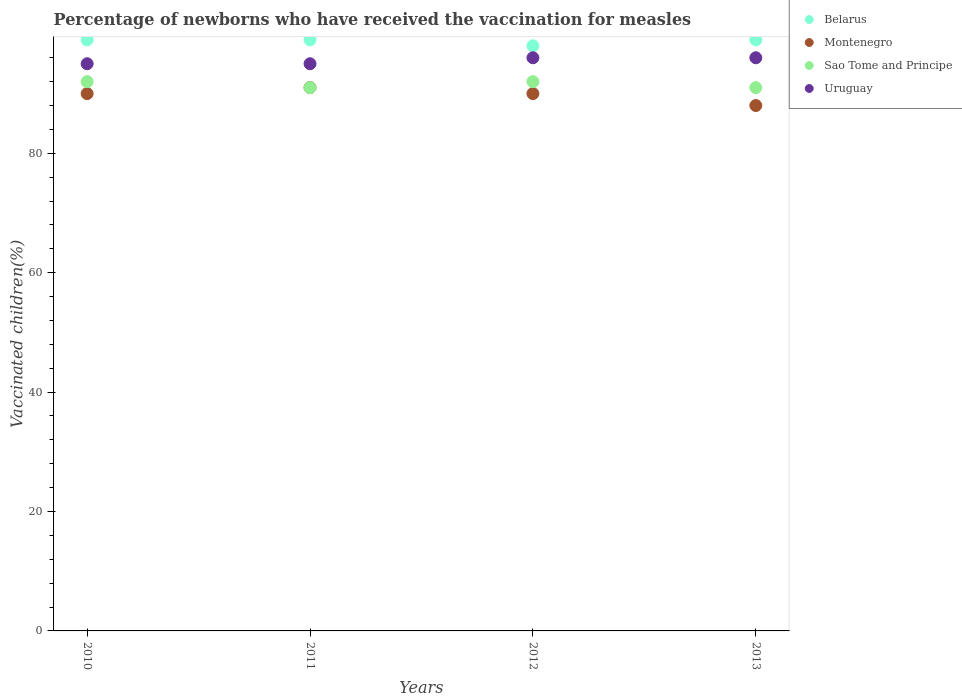How many different coloured dotlines are there?
Your answer should be very brief. 4. Is the number of dotlines equal to the number of legend labels?
Ensure brevity in your answer.  Yes. Across all years, what is the maximum percentage of vaccinated children in Sao Tome and Principe?
Provide a succinct answer. 92. In which year was the percentage of vaccinated children in Montenegro maximum?
Offer a terse response. 2011. What is the total percentage of vaccinated children in Montenegro in the graph?
Provide a short and direct response. 359. What is the difference between the percentage of vaccinated children in Uruguay in 2011 and that in 2013?
Ensure brevity in your answer.  -1. What is the difference between the percentage of vaccinated children in Sao Tome and Principe in 2011 and the percentage of vaccinated children in Montenegro in 2010?
Offer a terse response. 1. What is the average percentage of vaccinated children in Uruguay per year?
Your response must be concise. 95.5. In how many years, is the percentage of vaccinated children in Uruguay greater than 36 %?
Give a very brief answer. 4. What is the ratio of the percentage of vaccinated children in Belarus in 2012 to that in 2013?
Your answer should be very brief. 0.99. Is the percentage of vaccinated children in Belarus in 2010 less than that in 2011?
Ensure brevity in your answer.  No. What is the difference between the highest and the second highest percentage of vaccinated children in Montenegro?
Offer a very short reply. 1. Is it the case that in every year, the sum of the percentage of vaccinated children in Sao Tome and Principe and percentage of vaccinated children in Montenegro  is greater than the percentage of vaccinated children in Uruguay?
Offer a terse response. Yes. Does the percentage of vaccinated children in Belarus monotonically increase over the years?
Make the answer very short. No. Is the percentage of vaccinated children in Uruguay strictly less than the percentage of vaccinated children in Sao Tome and Principe over the years?
Offer a very short reply. No. How many years are there in the graph?
Your answer should be compact. 4. What is the difference between two consecutive major ticks on the Y-axis?
Offer a terse response. 20. Does the graph contain any zero values?
Make the answer very short. No. Does the graph contain grids?
Make the answer very short. No. Where does the legend appear in the graph?
Make the answer very short. Top right. What is the title of the graph?
Offer a terse response. Percentage of newborns who have received the vaccination for measles. What is the label or title of the Y-axis?
Make the answer very short. Vaccinated children(%). What is the Vaccinated children(%) of Belarus in 2010?
Your answer should be very brief. 99. What is the Vaccinated children(%) in Montenegro in 2010?
Your answer should be compact. 90. What is the Vaccinated children(%) of Sao Tome and Principe in 2010?
Ensure brevity in your answer.  92. What is the Vaccinated children(%) of Uruguay in 2010?
Ensure brevity in your answer.  95. What is the Vaccinated children(%) of Montenegro in 2011?
Provide a short and direct response. 91. What is the Vaccinated children(%) of Sao Tome and Principe in 2011?
Provide a succinct answer. 91. What is the Vaccinated children(%) in Uruguay in 2011?
Offer a terse response. 95. What is the Vaccinated children(%) in Montenegro in 2012?
Your response must be concise. 90. What is the Vaccinated children(%) in Sao Tome and Principe in 2012?
Your answer should be compact. 92. What is the Vaccinated children(%) of Uruguay in 2012?
Your answer should be compact. 96. What is the Vaccinated children(%) in Montenegro in 2013?
Your answer should be very brief. 88. What is the Vaccinated children(%) in Sao Tome and Principe in 2013?
Make the answer very short. 91. What is the Vaccinated children(%) of Uruguay in 2013?
Provide a succinct answer. 96. Across all years, what is the maximum Vaccinated children(%) of Montenegro?
Offer a terse response. 91. Across all years, what is the maximum Vaccinated children(%) in Sao Tome and Principe?
Keep it short and to the point. 92. Across all years, what is the maximum Vaccinated children(%) of Uruguay?
Ensure brevity in your answer.  96. Across all years, what is the minimum Vaccinated children(%) of Belarus?
Provide a succinct answer. 98. Across all years, what is the minimum Vaccinated children(%) of Sao Tome and Principe?
Your answer should be compact. 91. What is the total Vaccinated children(%) in Belarus in the graph?
Your answer should be compact. 395. What is the total Vaccinated children(%) in Montenegro in the graph?
Make the answer very short. 359. What is the total Vaccinated children(%) in Sao Tome and Principe in the graph?
Your answer should be compact. 366. What is the total Vaccinated children(%) in Uruguay in the graph?
Provide a succinct answer. 382. What is the difference between the Vaccinated children(%) in Belarus in 2010 and that in 2011?
Keep it short and to the point. 0. What is the difference between the Vaccinated children(%) in Belarus in 2010 and that in 2012?
Offer a terse response. 1. What is the difference between the Vaccinated children(%) of Sao Tome and Principe in 2010 and that in 2012?
Give a very brief answer. 0. What is the difference between the Vaccinated children(%) of Montenegro in 2010 and that in 2013?
Provide a short and direct response. 2. What is the difference between the Vaccinated children(%) in Sao Tome and Principe in 2010 and that in 2013?
Make the answer very short. 1. What is the difference between the Vaccinated children(%) of Belarus in 2011 and that in 2012?
Your response must be concise. 1. What is the difference between the Vaccinated children(%) of Montenegro in 2011 and that in 2012?
Your response must be concise. 1. What is the difference between the Vaccinated children(%) in Sao Tome and Principe in 2011 and that in 2012?
Provide a short and direct response. -1. What is the difference between the Vaccinated children(%) of Montenegro in 2011 and that in 2013?
Give a very brief answer. 3. What is the difference between the Vaccinated children(%) of Sao Tome and Principe in 2011 and that in 2013?
Your response must be concise. 0. What is the difference between the Vaccinated children(%) of Montenegro in 2012 and that in 2013?
Offer a very short reply. 2. What is the difference between the Vaccinated children(%) in Sao Tome and Principe in 2012 and that in 2013?
Ensure brevity in your answer.  1. What is the difference between the Vaccinated children(%) of Uruguay in 2012 and that in 2013?
Your answer should be very brief. 0. What is the difference between the Vaccinated children(%) in Belarus in 2010 and the Vaccinated children(%) in Montenegro in 2011?
Offer a terse response. 8. What is the difference between the Vaccinated children(%) of Montenegro in 2010 and the Vaccinated children(%) of Sao Tome and Principe in 2011?
Ensure brevity in your answer.  -1. What is the difference between the Vaccinated children(%) in Belarus in 2010 and the Vaccinated children(%) in Sao Tome and Principe in 2012?
Your response must be concise. 7. What is the difference between the Vaccinated children(%) in Montenegro in 2010 and the Vaccinated children(%) in Sao Tome and Principe in 2012?
Make the answer very short. -2. What is the difference between the Vaccinated children(%) of Sao Tome and Principe in 2010 and the Vaccinated children(%) of Uruguay in 2012?
Make the answer very short. -4. What is the difference between the Vaccinated children(%) of Belarus in 2010 and the Vaccinated children(%) of Sao Tome and Principe in 2013?
Your response must be concise. 8. What is the difference between the Vaccinated children(%) of Belarus in 2010 and the Vaccinated children(%) of Uruguay in 2013?
Your answer should be very brief. 3. What is the difference between the Vaccinated children(%) of Montenegro in 2010 and the Vaccinated children(%) of Uruguay in 2013?
Give a very brief answer. -6. What is the difference between the Vaccinated children(%) in Belarus in 2011 and the Vaccinated children(%) in Montenegro in 2012?
Your response must be concise. 9. What is the difference between the Vaccinated children(%) of Belarus in 2011 and the Vaccinated children(%) of Montenegro in 2013?
Give a very brief answer. 11. What is the difference between the Vaccinated children(%) in Montenegro in 2011 and the Vaccinated children(%) in Sao Tome and Principe in 2013?
Make the answer very short. 0. What is the difference between the Vaccinated children(%) in Belarus in 2012 and the Vaccinated children(%) in Montenegro in 2013?
Provide a succinct answer. 10. What is the difference between the Vaccinated children(%) of Belarus in 2012 and the Vaccinated children(%) of Uruguay in 2013?
Your response must be concise. 2. What is the difference between the Vaccinated children(%) in Sao Tome and Principe in 2012 and the Vaccinated children(%) in Uruguay in 2013?
Ensure brevity in your answer.  -4. What is the average Vaccinated children(%) in Belarus per year?
Make the answer very short. 98.75. What is the average Vaccinated children(%) in Montenegro per year?
Make the answer very short. 89.75. What is the average Vaccinated children(%) of Sao Tome and Principe per year?
Make the answer very short. 91.5. What is the average Vaccinated children(%) in Uruguay per year?
Keep it short and to the point. 95.5. In the year 2010, what is the difference between the Vaccinated children(%) of Belarus and Vaccinated children(%) of Montenegro?
Your answer should be compact. 9. In the year 2010, what is the difference between the Vaccinated children(%) of Montenegro and Vaccinated children(%) of Uruguay?
Make the answer very short. -5. In the year 2011, what is the difference between the Vaccinated children(%) of Belarus and Vaccinated children(%) of Montenegro?
Provide a succinct answer. 8. In the year 2011, what is the difference between the Vaccinated children(%) in Montenegro and Vaccinated children(%) in Sao Tome and Principe?
Provide a short and direct response. 0. In the year 2011, what is the difference between the Vaccinated children(%) of Sao Tome and Principe and Vaccinated children(%) of Uruguay?
Your answer should be very brief. -4. In the year 2012, what is the difference between the Vaccinated children(%) of Belarus and Vaccinated children(%) of Sao Tome and Principe?
Keep it short and to the point. 6. In the year 2012, what is the difference between the Vaccinated children(%) in Belarus and Vaccinated children(%) in Uruguay?
Ensure brevity in your answer.  2. In the year 2012, what is the difference between the Vaccinated children(%) of Montenegro and Vaccinated children(%) of Uruguay?
Provide a succinct answer. -6. In the year 2013, what is the difference between the Vaccinated children(%) in Belarus and Vaccinated children(%) in Montenegro?
Offer a terse response. 11. In the year 2013, what is the difference between the Vaccinated children(%) in Belarus and Vaccinated children(%) in Sao Tome and Principe?
Offer a very short reply. 8. In the year 2013, what is the difference between the Vaccinated children(%) of Belarus and Vaccinated children(%) of Uruguay?
Give a very brief answer. 3. In the year 2013, what is the difference between the Vaccinated children(%) in Montenegro and Vaccinated children(%) in Sao Tome and Principe?
Your response must be concise. -3. What is the ratio of the Vaccinated children(%) of Belarus in 2010 to that in 2011?
Ensure brevity in your answer.  1. What is the ratio of the Vaccinated children(%) in Montenegro in 2010 to that in 2011?
Keep it short and to the point. 0.99. What is the ratio of the Vaccinated children(%) in Uruguay in 2010 to that in 2011?
Offer a very short reply. 1. What is the ratio of the Vaccinated children(%) of Belarus in 2010 to that in 2012?
Your response must be concise. 1.01. What is the ratio of the Vaccinated children(%) of Sao Tome and Principe in 2010 to that in 2012?
Give a very brief answer. 1. What is the ratio of the Vaccinated children(%) of Uruguay in 2010 to that in 2012?
Your answer should be very brief. 0.99. What is the ratio of the Vaccinated children(%) of Montenegro in 2010 to that in 2013?
Make the answer very short. 1.02. What is the ratio of the Vaccinated children(%) in Sao Tome and Principe in 2010 to that in 2013?
Give a very brief answer. 1.01. What is the ratio of the Vaccinated children(%) in Uruguay in 2010 to that in 2013?
Provide a succinct answer. 0.99. What is the ratio of the Vaccinated children(%) in Belarus in 2011 to that in 2012?
Offer a very short reply. 1.01. What is the ratio of the Vaccinated children(%) in Montenegro in 2011 to that in 2012?
Provide a short and direct response. 1.01. What is the ratio of the Vaccinated children(%) of Belarus in 2011 to that in 2013?
Provide a short and direct response. 1. What is the ratio of the Vaccinated children(%) of Montenegro in 2011 to that in 2013?
Give a very brief answer. 1.03. What is the ratio of the Vaccinated children(%) of Belarus in 2012 to that in 2013?
Your answer should be compact. 0.99. What is the ratio of the Vaccinated children(%) of Montenegro in 2012 to that in 2013?
Your response must be concise. 1.02. What is the ratio of the Vaccinated children(%) in Sao Tome and Principe in 2012 to that in 2013?
Keep it short and to the point. 1.01. What is the difference between the highest and the second highest Vaccinated children(%) in Belarus?
Make the answer very short. 0. What is the difference between the highest and the second highest Vaccinated children(%) in Montenegro?
Your response must be concise. 1. What is the difference between the highest and the second highest Vaccinated children(%) in Sao Tome and Principe?
Provide a succinct answer. 0. What is the difference between the highest and the lowest Vaccinated children(%) of Belarus?
Offer a very short reply. 1. What is the difference between the highest and the lowest Vaccinated children(%) of Sao Tome and Principe?
Offer a very short reply. 1. 